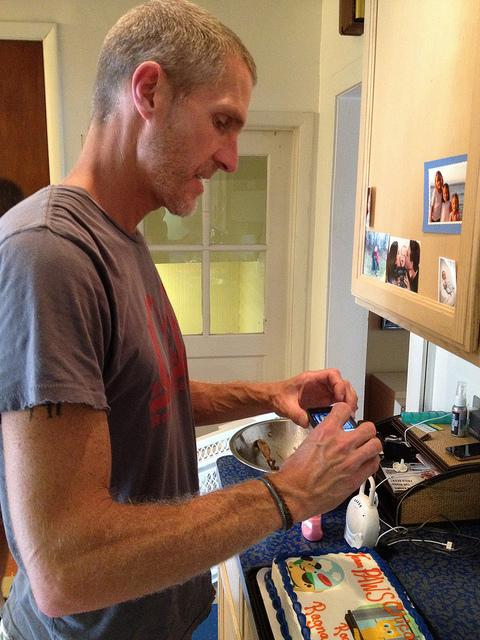What is the blue rectangular plastic item used to hold at the top of the desk?

Choices:
A) pills
B) stickers
C) screws
D) thumbtacks pills 